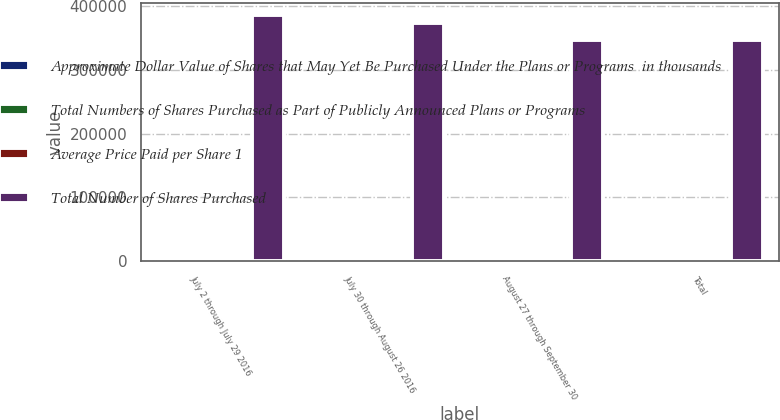Convert chart to OTSL. <chart><loc_0><loc_0><loc_500><loc_500><stacked_bar_chart><ecel><fcel>July 2 through July 29 2016<fcel>July 30 through August 26 2016<fcel>August 27 through September 30<fcel>Total<nl><fcel>Approximate Dollar Value of Shares that May Yet Be Purchased Under the Plans or Programs  in thousands<fcel>227<fcel>213<fcel>522<fcel>962<nl><fcel>Total Numbers of Shares Purchased as Part of Publicly Announced Plans or Programs<fcel>52.3<fcel>53.77<fcel>51.32<fcel>52.1<nl><fcel>Average Price Paid per Share 1<fcel>227<fcel>213<fcel>522<fcel>962<nl><fcel>Total Number of Shares Purchased<fcel>385665<fcel>374211<fcel>347451<fcel>347451<nl></chart> 